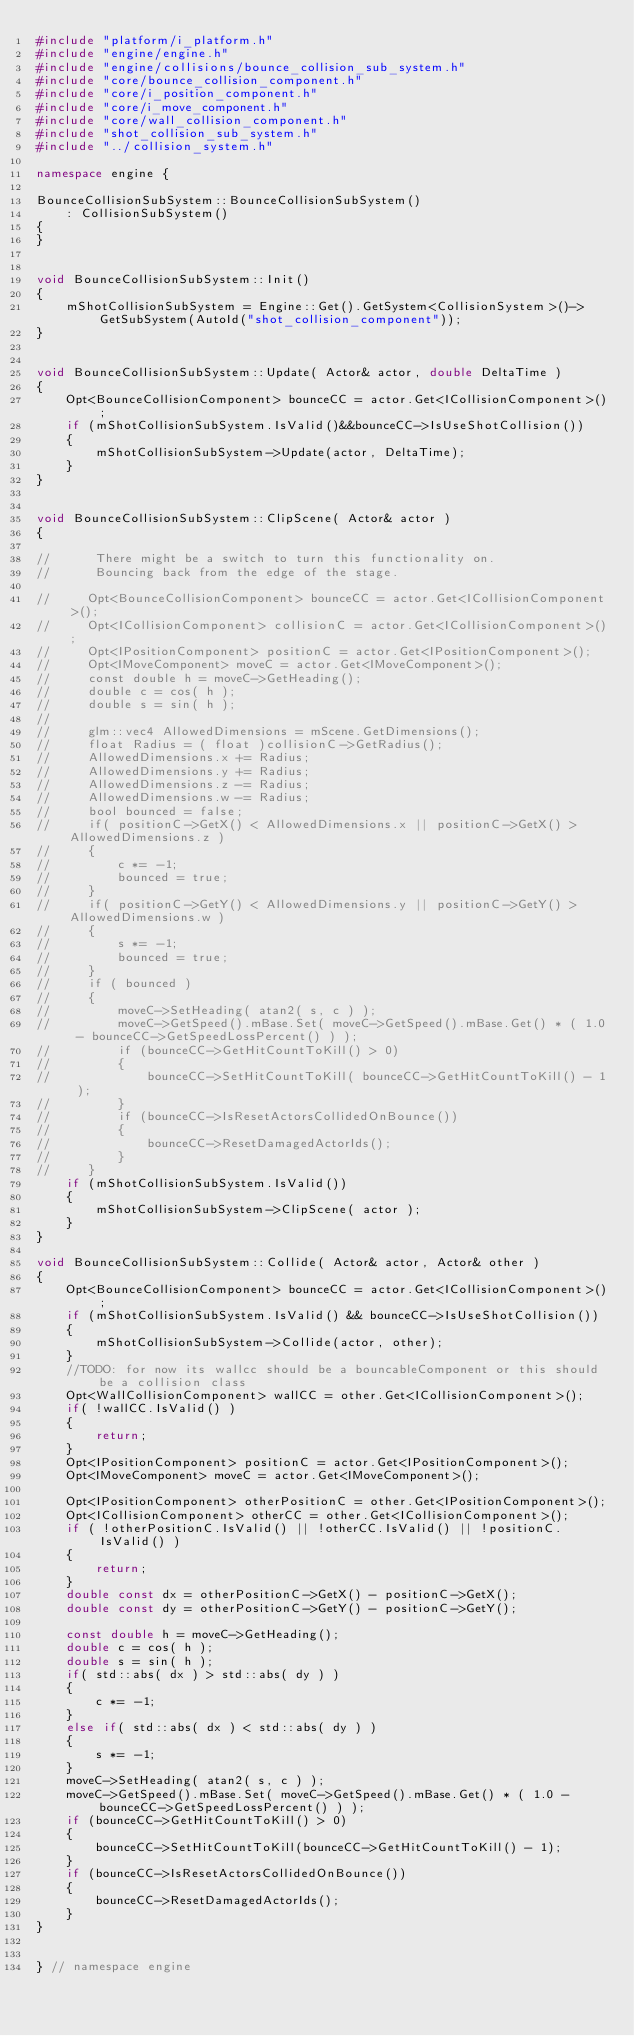<code> <loc_0><loc_0><loc_500><loc_500><_C++_>#include "platform/i_platform.h"
#include "engine/engine.h"
#include "engine/collisions/bounce_collision_sub_system.h"
#include "core/bounce_collision_component.h"
#include "core/i_position_component.h"
#include "core/i_move_component.h"
#include "core/wall_collision_component.h"
#include "shot_collision_sub_system.h"
#include "../collision_system.h"

namespace engine {

BounceCollisionSubSystem::BounceCollisionSubSystem()
    : CollisionSubSystem()
{
}


void BounceCollisionSubSystem::Init()
{
    mShotCollisionSubSystem = Engine::Get().GetSystem<CollisionSystem>()->GetSubSystem(AutoId("shot_collision_component"));
}


void BounceCollisionSubSystem::Update( Actor& actor, double DeltaTime )
{
    Opt<BounceCollisionComponent> bounceCC = actor.Get<ICollisionComponent>();
    if (mShotCollisionSubSystem.IsValid()&&bounceCC->IsUseShotCollision())
    {
        mShotCollisionSubSystem->Update(actor, DeltaTime);
    }
}


void BounceCollisionSubSystem::ClipScene( Actor& actor )
{

//      There might be a switch to turn this functionality on.
//      Bouncing back from the edge of the stage.

//     Opt<BounceCollisionComponent> bounceCC = actor.Get<ICollisionComponent>();
//     Opt<ICollisionComponent> collisionC = actor.Get<ICollisionComponent>();
//     Opt<IPositionComponent> positionC = actor.Get<IPositionComponent>();
//     Opt<IMoveComponent> moveC = actor.Get<IMoveComponent>();
//     const double h = moveC->GetHeading();
//     double c = cos( h );
//     double s = sin( h );
// 
//     glm::vec4 AllowedDimensions = mScene.GetDimensions();
//     float Radius = ( float )collisionC->GetRadius();
//     AllowedDimensions.x += Radius;
//     AllowedDimensions.y += Radius;
//     AllowedDimensions.z -= Radius;
//     AllowedDimensions.w -= Radius;
//     bool bounced = false;
//     if( positionC->GetX() < AllowedDimensions.x || positionC->GetX() > AllowedDimensions.z )
//     {
//         c *= -1;
//         bounced = true;
//     }
//     if( positionC->GetY() < AllowedDimensions.y || positionC->GetY() > AllowedDimensions.w )
//     {
//         s *= -1;
//         bounced = true;
//     }
//     if ( bounced )
//     {
//         moveC->SetHeading( atan2( s, c ) );
//         moveC->GetSpeed().mBase.Set( moveC->GetSpeed().mBase.Get() * ( 1.0 - bounceCC->GetSpeedLossPercent() ) );
//         if (bounceCC->GetHitCountToKill() > 0)
//         {
//             bounceCC->SetHitCountToKill( bounceCC->GetHitCountToKill() - 1 );
//         }
//         if (bounceCC->IsResetActorsCollidedOnBounce())
//         {
//             bounceCC->ResetDamagedActorIds();
//         }
//     }
    if (mShotCollisionSubSystem.IsValid())
    {
        mShotCollisionSubSystem->ClipScene( actor );
    }
}

void BounceCollisionSubSystem::Collide( Actor& actor, Actor& other )
{
    Opt<BounceCollisionComponent> bounceCC = actor.Get<ICollisionComponent>();
    if (mShotCollisionSubSystem.IsValid() && bounceCC->IsUseShotCollision())
    {
        mShotCollisionSubSystem->Collide(actor, other);
    }
    //TODO: for now its wallcc should be a bouncableComponent or this should be a collision class
    Opt<WallCollisionComponent> wallCC = other.Get<ICollisionComponent>();
    if( !wallCC.IsValid() )
    {
        return;
    }
    Opt<IPositionComponent> positionC = actor.Get<IPositionComponent>();
    Opt<IMoveComponent> moveC = actor.Get<IMoveComponent>();

    Opt<IPositionComponent> otherPositionC = other.Get<IPositionComponent>();
    Opt<ICollisionComponent> otherCC = other.Get<ICollisionComponent>();
    if ( !otherPositionC.IsValid() || !otherCC.IsValid() || !positionC.IsValid() )
    {
        return;
    }
    double const dx = otherPositionC->GetX() - positionC->GetX();
    double const dy = otherPositionC->GetY() - positionC->GetY();

    const double h = moveC->GetHeading();
    double c = cos( h );
    double s = sin( h );
    if( std::abs( dx ) > std::abs( dy ) )
    {
        c *= -1;
    }
    else if( std::abs( dx ) < std::abs( dy ) )
    {
        s *= -1;
    }
    moveC->SetHeading( atan2( s, c ) );
    moveC->GetSpeed().mBase.Set( moveC->GetSpeed().mBase.Get() * ( 1.0 - bounceCC->GetSpeedLossPercent() ) );
    if (bounceCC->GetHitCountToKill() > 0)
    {
        bounceCC->SetHitCountToKill(bounceCC->GetHitCountToKill() - 1);
    }
    if (bounceCC->IsResetActorsCollidedOnBounce())
    {
        bounceCC->ResetDamagedActorIds();
    }
}


} // namespace engine

</code> 